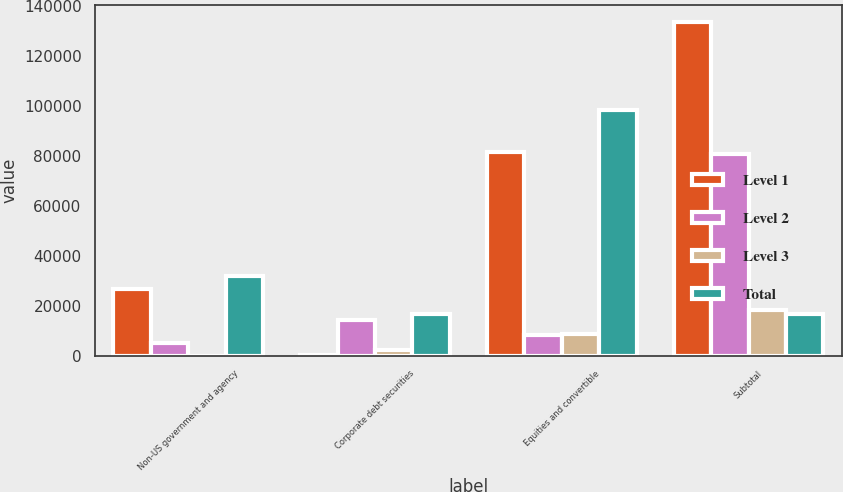Convert chart to OTSL. <chart><loc_0><loc_0><loc_500><loc_500><stacked_bar_chart><ecel><fcel>Non-US government and agency<fcel>Corporate debt securities<fcel>Equities and convertible<fcel>Subtotal<nl><fcel>Level 1<fcel>26500<fcel>218<fcel>81252<fcel>133439<nl><fcel>Level 2<fcel>5260<fcel>14330<fcel>8271<fcel>80723<nl><fcel>Level 3<fcel>12<fcel>2092<fcel>8549<fcel>18131<nl><fcel>Total<fcel>31772<fcel>16640<fcel>98072<fcel>16640<nl></chart> 